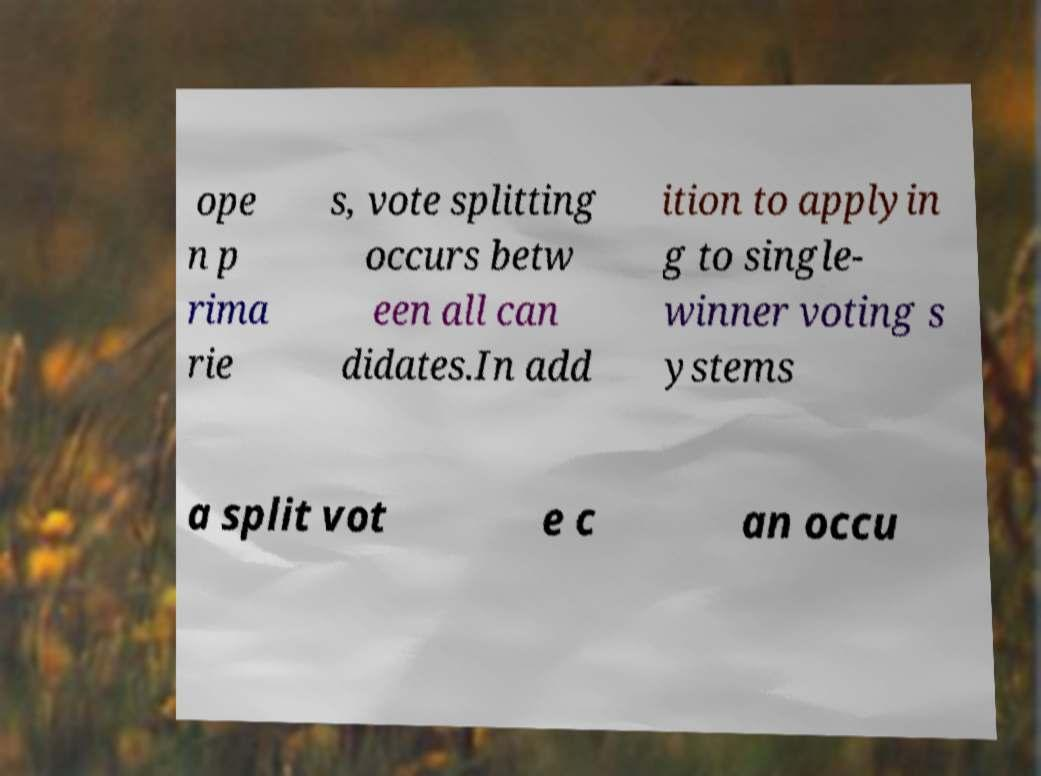What concept is discussed in the text shown in this image? The text discusses the concept of 'open primaries' and 'vote splitting'. Open primaries allow voters of any party affiliation to vote in any party's primary, which can lead to vote splitting where the votes are divided among many candidates, potentially diluting the strength of collective voting preferences. 